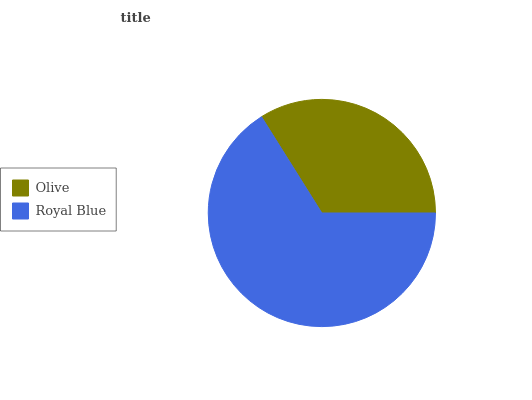Is Olive the minimum?
Answer yes or no. Yes. Is Royal Blue the maximum?
Answer yes or no. Yes. Is Royal Blue the minimum?
Answer yes or no. No. Is Royal Blue greater than Olive?
Answer yes or no. Yes. Is Olive less than Royal Blue?
Answer yes or no. Yes. Is Olive greater than Royal Blue?
Answer yes or no. No. Is Royal Blue less than Olive?
Answer yes or no. No. Is Royal Blue the high median?
Answer yes or no. Yes. Is Olive the low median?
Answer yes or no. Yes. Is Olive the high median?
Answer yes or no. No. Is Royal Blue the low median?
Answer yes or no. No. 